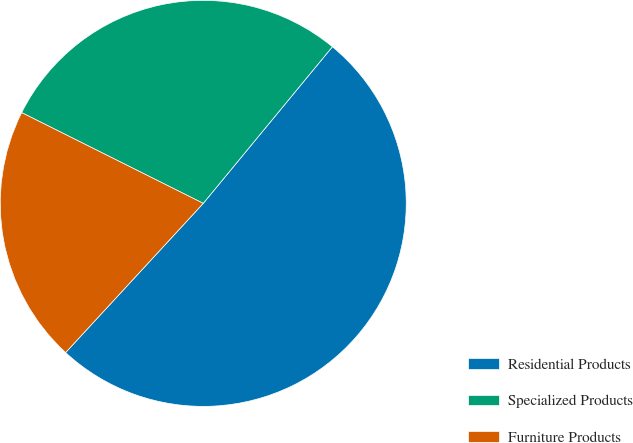<chart> <loc_0><loc_0><loc_500><loc_500><pie_chart><fcel>Residential Products<fcel>Specialized Products<fcel>Furniture Products<nl><fcel>50.89%<fcel>28.6%<fcel>20.52%<nl></chart> 